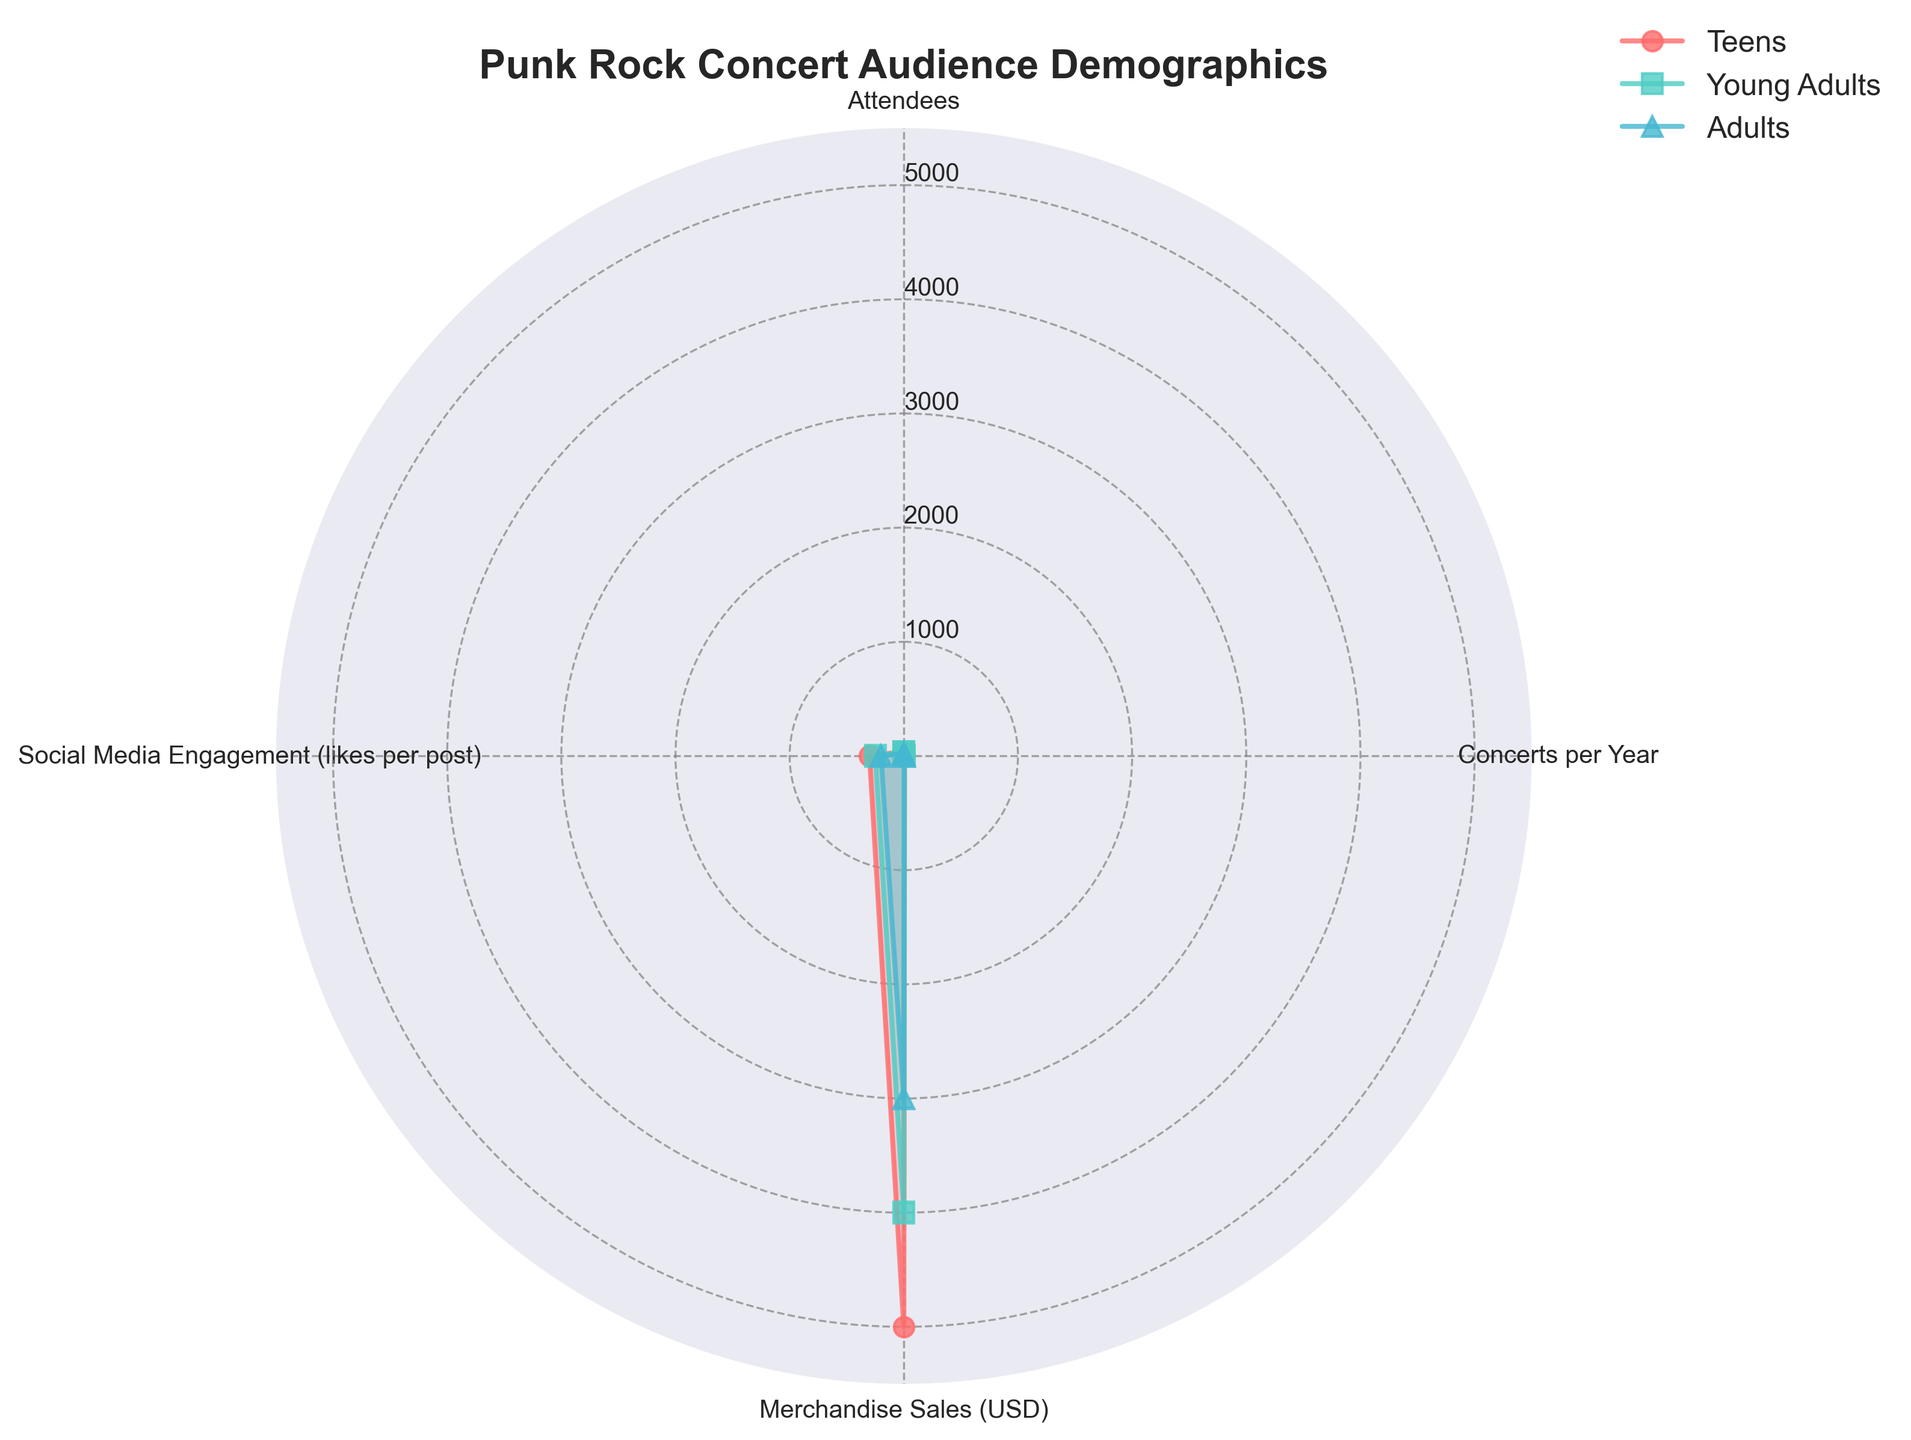What is the group with the highest number of attendees? The radar chart shows 'Attendees' as one of the categories. The group with the longest line in this category is 'Teens'.
Answer: Teens Which age group has the lowest social media engagement? To determine this, look at the 'Social Media Engagement (likes per post)' category in the radar chart. The group with the shortest line in this category is 'Adults'.
Answer: Adults How many concerts do Young Adults attend per year? Refer to the 'Concerts per Year' section of the radar chart for the Young Adults group. The numerical value indicated by the line is 5.
Answer: 5 What is the total merchandise sales for Teens and Adults? On the radar chart, find the 'Merchandise Sales (USD)' values for Teens and Adults categories and sum them up. For Teens, it's $5000 and for Adults, it's $3000. So the total is $5000 + $3000.
Answer: $8000 How do merchandise sales compare between Teens and Young Adults? Look at the 'Merchandise Sales (USD)' category on the radar chart. Teens have $5000 and Young Adults have $4000. Teens have higher merchandise sales than Young Adults by $1000.
Answer: Teens have higher sales by $1000 Which group participates in the most categories? This question is interpreted as which group has higher values across multiple categories. By visually comparing the overall area enclosed by the lines for each group, the group with the most prominent area is 'Teens'.
Answer: Teens What is the average number of concerts attended per year across all age groups? Find the 'Concerts per Year' values from the radar chart for all age groups. Add them up and divide by the number of groups. (6 + 5 + 4) / 3 = 15 / 3
Answer: 5 Which age group has the smallest area on the radar chart? Visually assess the area enclosed by the lines for each age group. The 'Adults' group has the smallest enclosed area in the radar chart.
Answer: Adults 